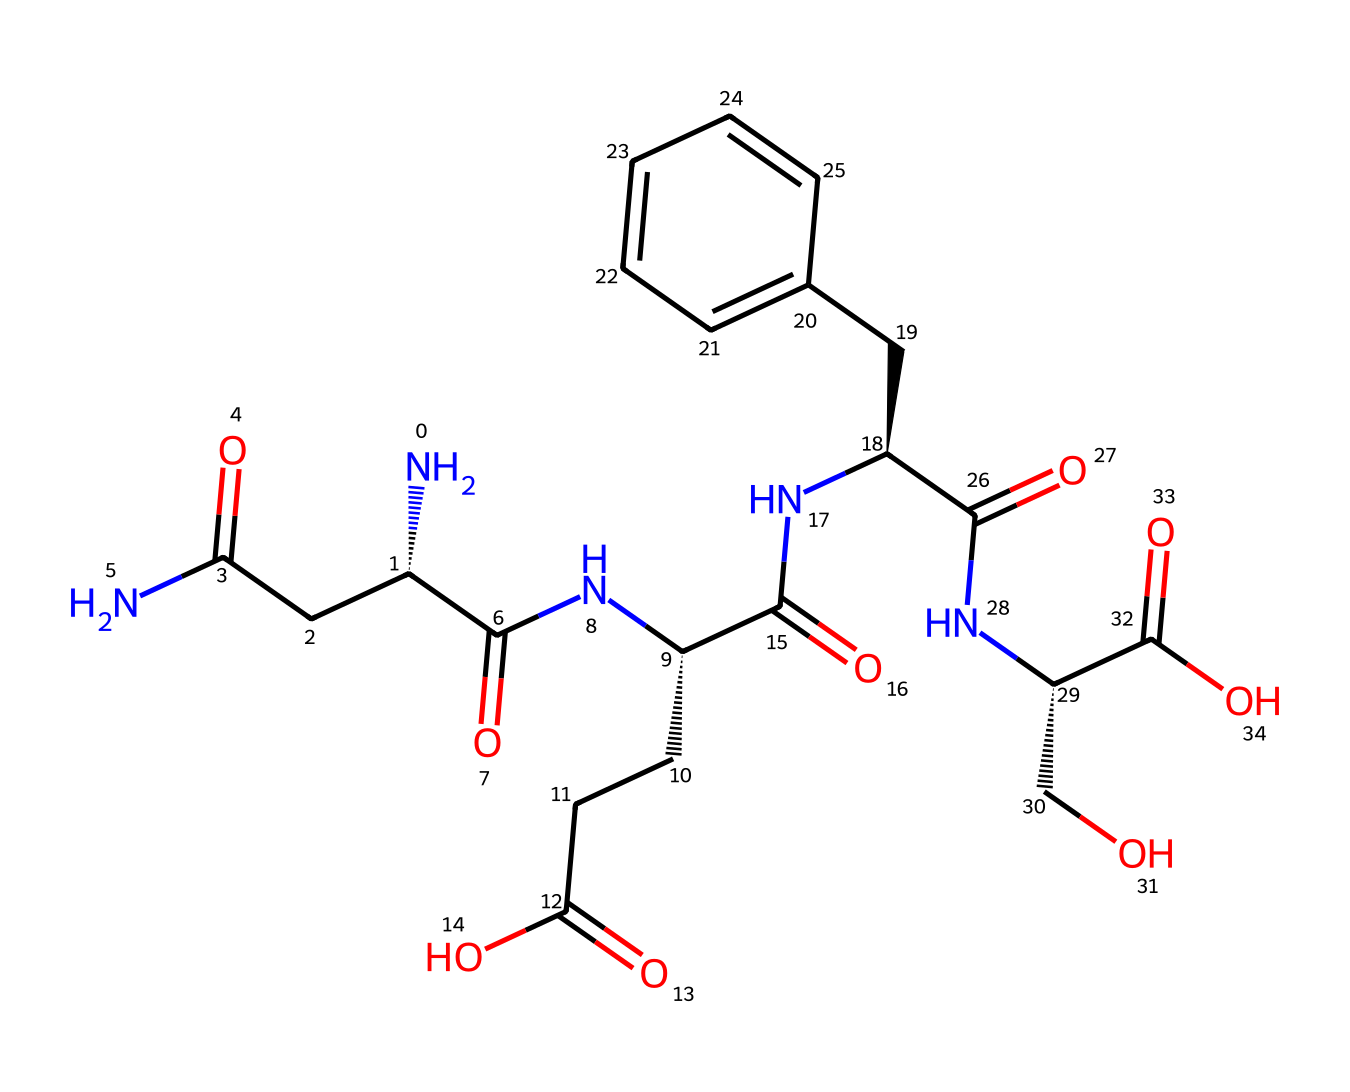What is the total number of amino acid residues in this structure? The provided SMILES represents a peptide chain composed of multiple amino acid residues. By analyzing the sequence, we can spot the repeating pattern characteristic of amino acids. In this structure, there are six distinct amine groups indicated by the 'N' atoms in the SMILES, which correspond to six amino acid residues.
Answer: six How many carbon atoms are present in this molecule? To find the number of carbon atoms, we can count the 'C' symbols in the SMILES representation. There are 19 carbon atoms indicated by the 'C' notations throughout the structure.
Answer: nineteen What type of bonds link the amino acids in this peptide? The presence of 'N' and 'C(=O)' in the SMILES indicates that the amino acids are linked by peptide bonds which are formed between the carboxyl group of one amino acid and the amino group of another, resulting in an amide bond.
Answer: peptide bonds What functional group is indicated by the 'C(=O)O' in the structure? The 'C(=O)O' notation refers to a carboxylic acid functional group, which is characterized by a carbon atom double-bonded to an oxygen atom and also bonded to a hydroxyl group (-OH). This group is involved in maintaining the acidity of the structure.
Answer: carboxylic acid Which part of the structure contributes to silk's tensile strength? Silk fibers' tensile strength comes from the ordered arrangement of amino acids and the presence of hydrogen bonds and hydrophobic interactions within the backbone. The multiple amide linkages formed by the peptide bonds enhance structural integrity.
Answer: amide linkages What type of polymer is represented by this chemical structure? The chemical structure is a type of protein polymer, specifically a polypeptide chain, which comprises repeating units of amino acids. This results in a large biomolecule that displays complex structural properties, characteristic of silk fibers.
Answer: protein polymer 